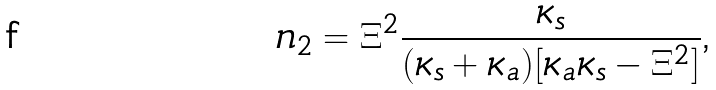<formula> <loc_0><loc_0><loc_500><loc_500>n _ { 2 } = \Xi ^ { 2 } \frac { \kappa _ { s } } { ( \kappa _ { s } + \kappa _ { a } ) [ \kappa _ { a } \kappa _ { s } - \Xi ^ { 2 } ] } \text {,}</formula> 